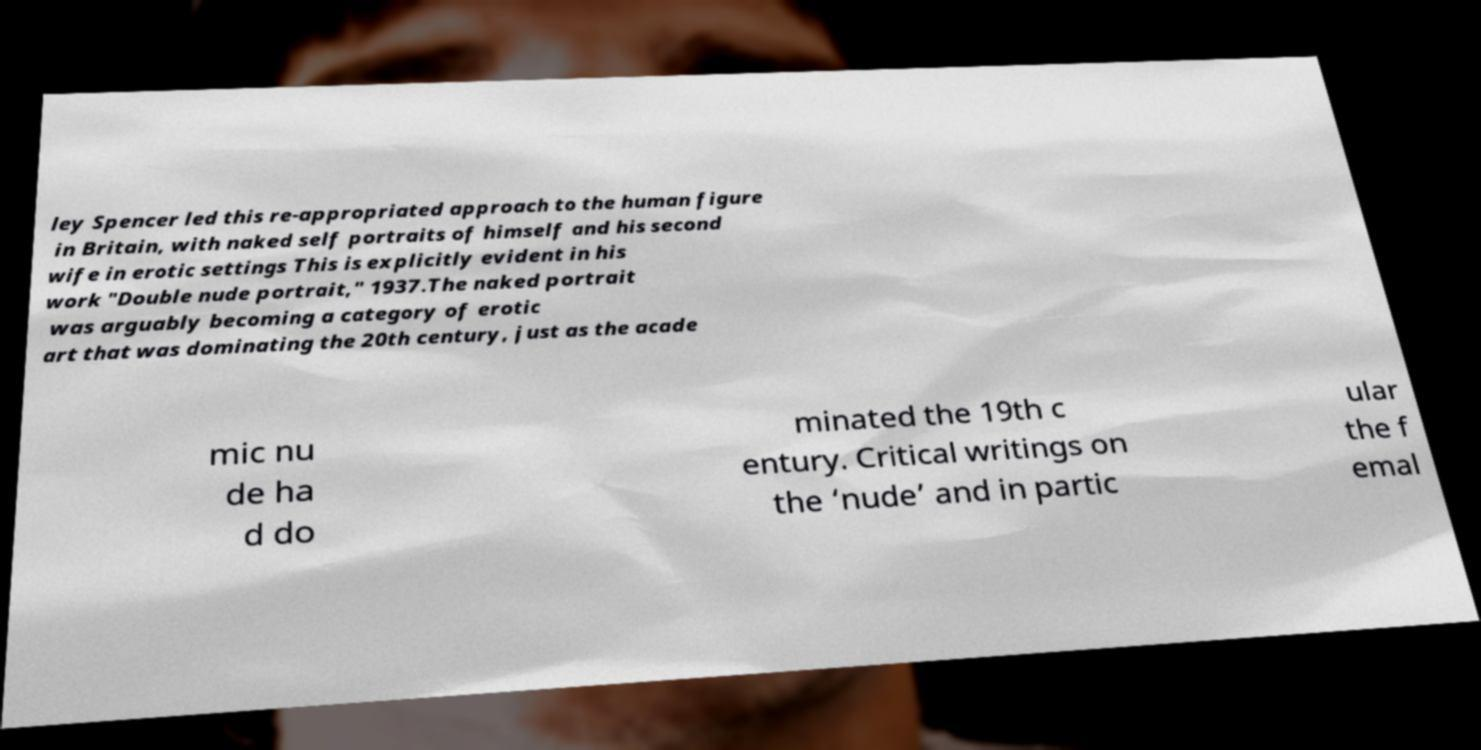Can you read and provide the text displayed in the image?This photo seems to have some interesting text. Can you extract and type it out for me? ley Spencer led this re-appropriated approach to the human figure in Britain, with naked self portraits of himself and his second wife in erotic settings This is explicitly evident in his work "Double nude portrait," 1937.The naked portrait was arguably becoming a category of erotic art that was dominating the 20th century, just as the acade mic nu de ha d do minated the 19th c entury. Critical writings on the ‘nude’ and in partic ular the f emal 